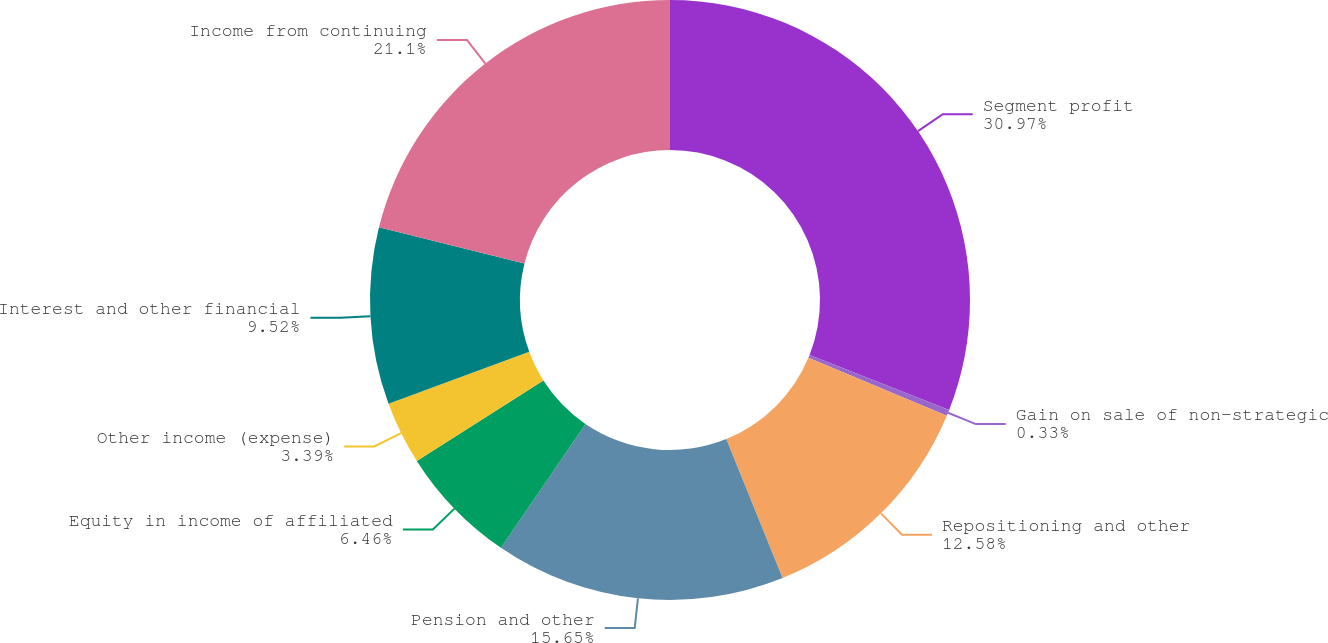<chart> <loc_0><loc_0><loc_500><loc_500><pie_chart><fcel>Segment profit<fcel>Gain on sale of non-strategic<fcel>Repositioning and other<fcel>Pension and other<fcel>Equity in income of affiliated<fcel>Other income (expense)<fcel>Interest and other financial<fcel>Income from continuing<nl><fcel>30.97%<fcel>0.33%<fcel>12.58%<fcel>15.65%<fcel>6.46%<fcel>3.39%<fcel>9.52%<fcel>21.1%<nl></chart> 